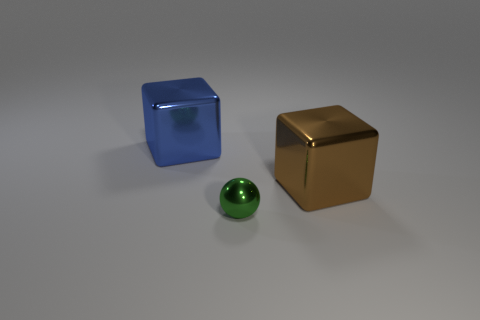What color is the metallic object that is in front of the big blue thing and behind the green metallic object?
Your answer should be very brief. Brown. There is a brown cube; what number of tiny metallic balls are in front of it?
Your answer should be very brief. 1. How many objects are large blue metallic objects or objects that are on the right side of the big blue thing?
Keep it short and to the point. 3. Is there a small metallic ball that is on the right side of the brown metal cube that is behind the small green sphere?
Provide a succinct answer. No. There is a metallic block that is to the left of the brown thing; what is its color?
Your answer should be compact. Blue. Is the number of blue metallic blocks that are in front of the blue thing the same as the number of large brown blocks?
Offer a terse response. No. What shape is the object that is behind the small green metal ball and left of the big brown metal object?
Your answer should be compact. Cube. What color is the other thing that is the same shape as the large brown shiny object?
Ensure brevity in your answer.  Blue. Is there any other thing that has the same color as the metal ball?
Your answer should be very brief. No. What is the shape of the green object to the left of the large metallic thing that is in front of the big metallic cube that is left of the tiny ball?
Give a very brief answer. Sphere. 